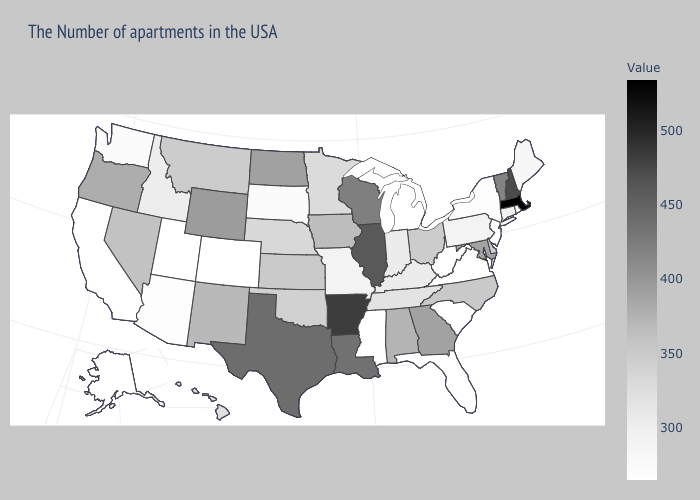Among the states that border Maryland , does Pennsylvania have the highest value?
Write a very short answer. No. Is the legend a continuous bar?
Concise answer only. Yes. Is the legend a continuous bar?
Keep it brief. Yes. Does Illinois have the highest value in the MidWest?
Be succinct. Yes. 